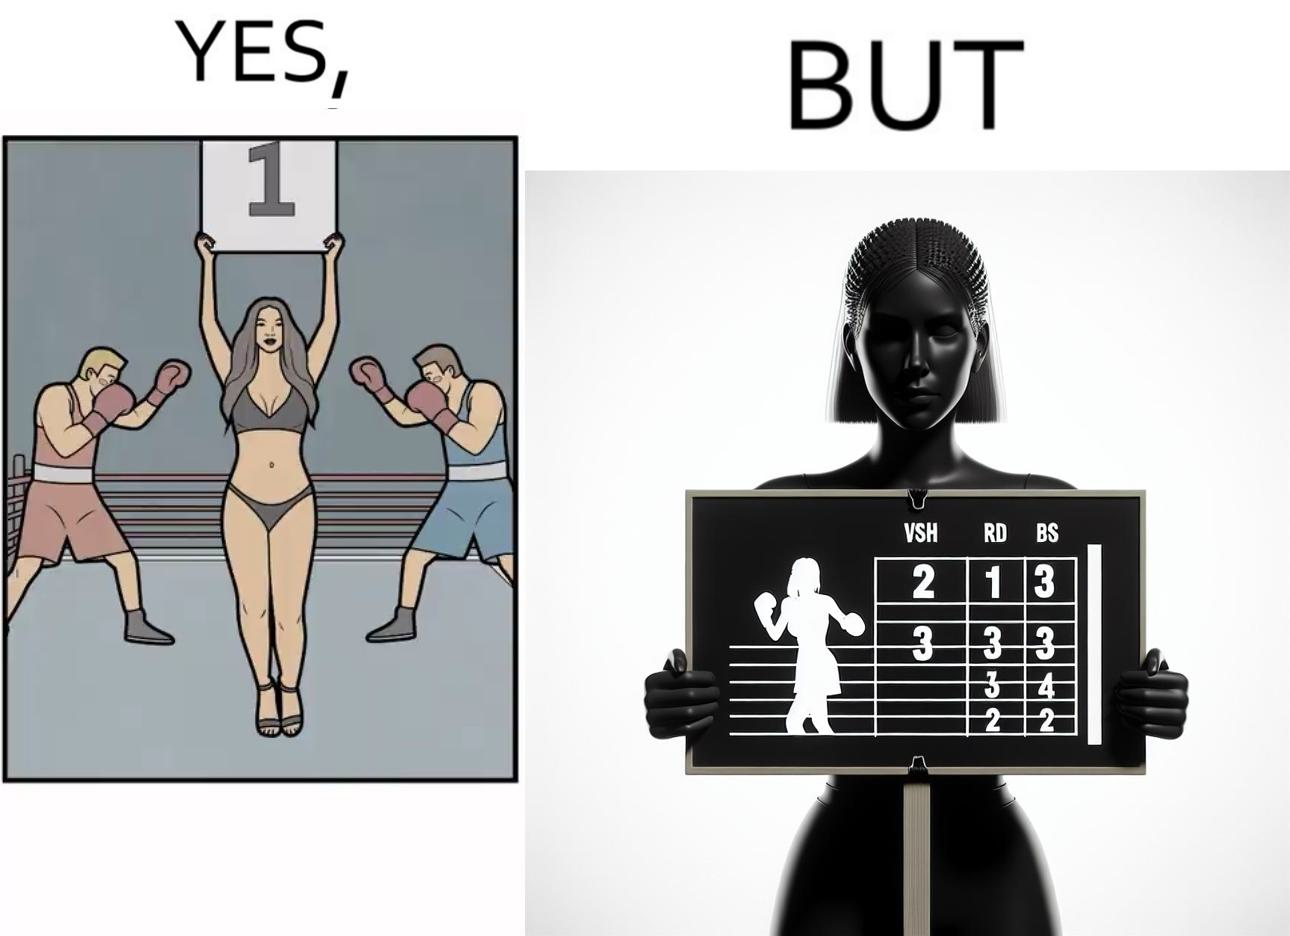Provide a description of this image. This is a satirical image with contrasting elements. 